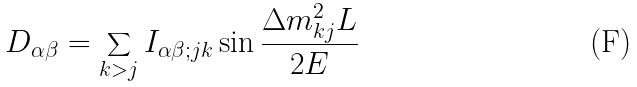<formula> <loc_0><loc_0><loc_500><loc_500>D _ { \alpha \beta } = \sum _ { k > j } I _ { \alpha \beta ; j k } \sin \frac { \Delta m _ { k j } ^ { 2 } L } { 2 E }</formula> 